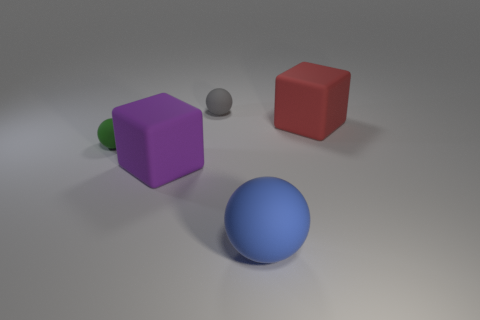Are there any small cylinders?
Offer a terse response. No. Are there more big matte objects that are behind the big blue rubber object than large blue rubber balls that are behind the gray matte ball?
Your answer should be very brief. Yes. What is the shape of the large purple object?
Your response must be concise. Cube. Are there more big red things that are in front of the tiny gray object than small yellow shiny things?
Your response must be concise. Yes. What is the shape of the rubber thing behind the red thing?
Provide a short and direct response. Sphere. How many other objects are the same shape as the big blue object?
Keep it short and to the point. 2. Is the material of the tiny ball that is in front of the red matte cube the same as the red thing?
Provide a succinct answer. Yes. Are there the same number of large spheres to the left of the large blue thing and small matte balls behind the red matte object?
Make the answer very short. No. There is a rubber ball right of the tiny gray rubber sphere; what size is it?
Offer a terse response. Large. Are there any large things that have the same material as the small green ball?
Make the answer very short. Yes. 